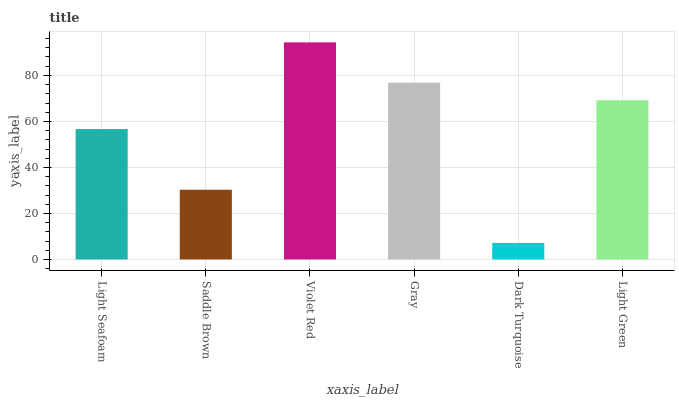Is Dark Turquoise the minimum?
Answer yes or no. Yes. Is Violet Red the maximum?
Answer yes or no. Yes. Is Saddle Brown the minimum?
Answer yes or no. No. Is Saddle Brown the maximum?
Answer yes or no. No. Is Light Seafoam greater than Saddle Brown?
Answer yes or no. Yes. Is Saddle Brown less than Light Seafoam?
Answer yes or no. Yes. Is Saddle Brown greater than Light Seafoam?
Answer yes or no. No. Is Light Seafoam less than Saddle Brown?
Answer yes or no. No. Is Light Green the high median?
Answer yes or no. Yes. Is Light Seafoam the low median?
Answer yes or no. Yes. Is Dark Turquoise the high median?
Answer yes or no. No. Is Saddle Brown the low median?
Answer yes or no. No. 